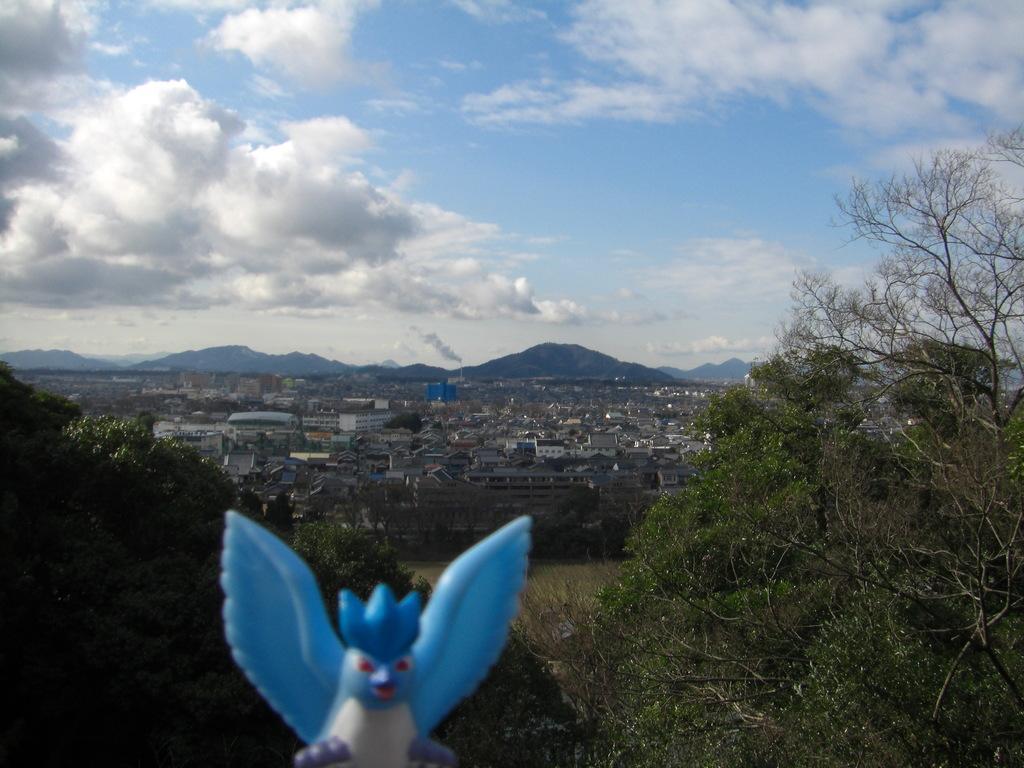How would you summarize this image in a sentence or two? This is an aerial view. In this picture we can see the mountains, buildings. At the bottom of the image we can see the trees, grass and object. At the top of the image we can see the clouds are present in the sky. 